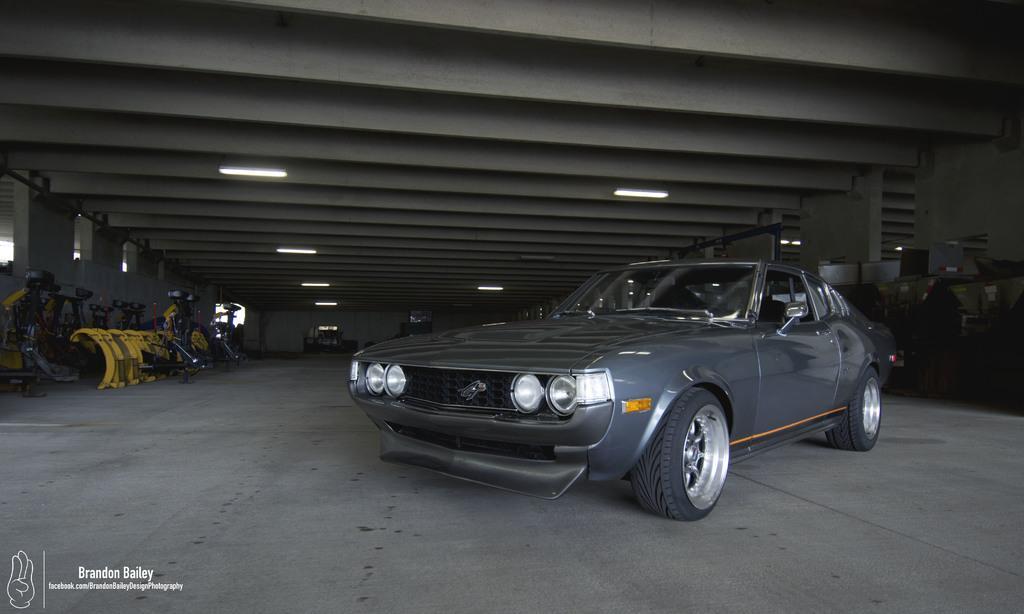Can you describe this image briefly? This image consists of a car in gray color. At the bottom, there is a floor. It looks like a garage. On the left, there are many things kept. At the top, there is a roof to which lights are fixed. 